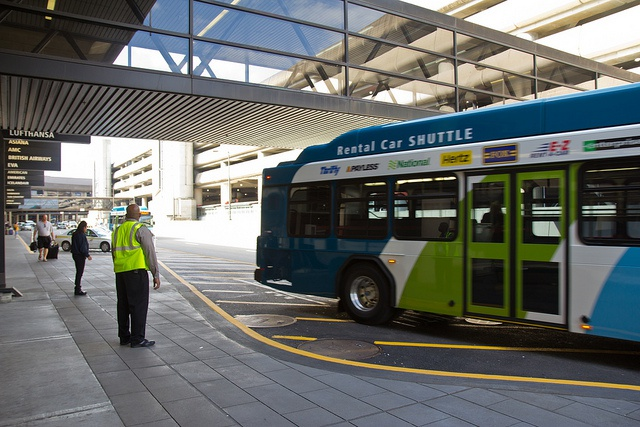Describe the objects in this image and their specific colors. I can see bus in black, gray, darkblue, and darkgreen tones, people in black, gray, olive, and darkgreen tones, people in black, darkgray, gray, and white tones, people in black, gray, darkgray, and lightgray tones, and car in black, darkgray, gray, and white tones in this image. 